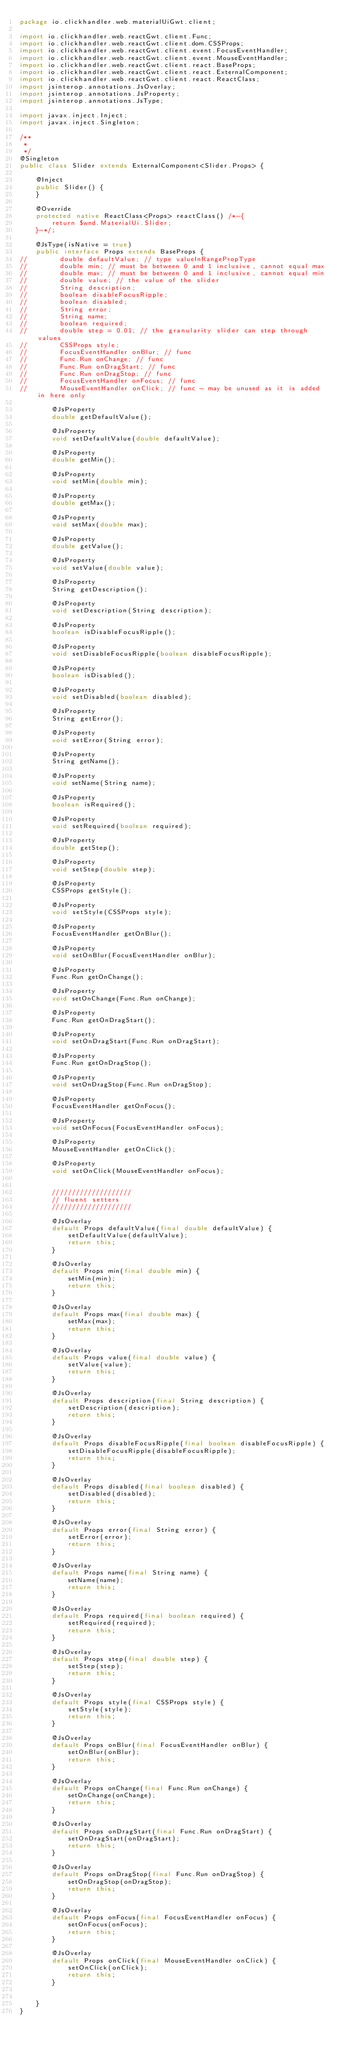Convert code to text. <code><loc_0><loc_0><loc_500><loc_500><_Java_>package io.clickhandler.web.materialUiGwt.client;

import io.clickhandler.web.reactGwt.client.Func;
import io.clickhandler.web.reactGwt.client.dom.CSSProps;
import io.clickhandler.web.reactGwt.client.event.FocusEventHandler;
import io.clickhandler.web.reactGwt.client.event.MouseEventHandler;
import io.clickhandler.web.reactGwt.client.react.BaseProps;
import io.clickhandler.web.reactGwt.client.react.ExternalComponent;
import io.clickhandler.web.reactGwt.client.react.ReactClass;
import jsinterop.annotations.JsOverlay;
import jsinterop.annotations.JsProperty;
import jsinterop.annotations.JsType;

import javax.inject.Inject;
import javax.inject.Singleton;

/**
 *
 */
@Singleton
public class Slider extends ExternalComponent<Slider.Props> {

    @Inject
    public Slider() {
    }

    @Override
    protected native ReactClass<Props> reactClass() /*-{
        return $wnd.MaterialUi.Slider;
    }-*/;

    @JsType(isNative = true)
    public interface Props extends BaseProps {
//        double defaultValue; // type valueInRangePropType
//        double min; // must be between 0 and 1 inclusive, cannot equal max
//        double max; // must be between 0 and 1 inclusive, cannot equal min
//        double value; // the value of the slider
//        String description;
//        boolean disableFocusRipple;
//        boolean disabled;
//        String error;
//        String name;
//        boolean required;
//        double step = 0.01; // the granularity slider can step through values
//        CSSProps style;
//        FocusEventHandler onBlur; // func
//        Func.Run onChange; // func
//        Func.Run onDragStart; // func
//        Func.Run onDragStop; // func
//        FocusEventHandler onFocus; // func
//        MouseEventHandler onClick; // func - may be unused as it is added in here only

        @JsProperty
        double getDefaultValue();

        @JsProperty
        void setDefaultValue(double defaultValue);

        @JsProperty
        double getMin();

        @JsProperty
        void setMin(double min);

        @JsProperty
        double getMax();

        @JsProperty
        void setMax(double max);

        @JsProperty
        double getValue();

        @JsProperty
        void setValue(double value);

        @JsProperty
        String getDescription();

        @JsProperty
        void setDescription(String description);

        @JsProperty
        boolean isDisableFocusRipple();

        @JsProperty
        void setDisableFocusRipple(boolean disableFocusRipple);

        @JsProperty
        boolean isDisabled();

        @JsProperty
        void setDisabled(boolean disabled);

        @JsProperty
        String getError();

        @JsProperty
        void setError(String error);

        @JsProperty
        String getName();

        @JsProperty
        void setName(String name);

        @JsProperty
        boolean isRequired();

        @JsProperty
        void setRequired(boolean required);

        @JsProperty
        double getStep();

        @JsProperty
        void setStep(double step);

        @JsProperty
        CSSProps getStyle();

        @JsProperty
        void setStyle(CSSProps style);

        @JsProperty
        FocusEventHandler getOnBlur();

        @JsProperty
        void setOnBlur(FocusEventHandler onBlur);

        @JsProperty
        Func.Run getOnChange();

        @JsProperty
        void setOnChange(Func.Run onChange);

        @JsProperty
        Func.Run getOnDragStart();

        @JsProperty
        void setOnDragStart(Func.Run onDragStart);

        @JsProperty
        Func.Run getOnDragStop();

        @JsProperty
        void setOnDragStop(Func.Run onDragStop);

        @JsProperty
        FocusEventHandler getOnFocus();

        @JsProperty
        void setOnFocus(FocusEventHandler onFocus);

        @JsProperty
        MouseEventHandler getOnClick();

        @JsProperty
        void setOnClick(MouseEventHandler onFocus);


        ////////////////////
        // fluent setters
        ////////////////////

        @JsOverlay
        default Props defaultValue(final double defaultValue) {
            setDefaultValue(defaultValue);
            return this;
        }

        @JsOverlay
        default Props min(final double min) {
            setMin(min);
            return this;
        }

        @JsOverlay
        default Props max(final double max) {
            setMax(max);
            return this;
        }

        @JsOverlay
        default Props value(final double value) {
            setValue(value);
            return this;
        }

        @JsOverlay
        default Props description(final String description) {
            setDescription(description);
            return this;
        }

        @JsOverlay
        default Props disableFocusRipple(final boolean disableFocusRipple) {
            setDisableFocusRipple(disableFocusRipple);
            return this;
        }

        @JsOverlay
        default Props disabled(final boolean disabled) {
            setDisabled(disabled);
            return this;
        }

        @JsOverlay
        default Props error(final String error) {
            setError(error);
            return this;
        }

        @JsOverlay
        default Props name(final String name) {
            setName(name);
            return this;
        }

        @JsOverlay
        default Props required(final boolean required) {
            setRequired(required);
            return this;
        }

        @JsOverlay
        default Props step(final double step) {
            setStep(step);
            return this;
        }

        @JsOverlay
        default Props style(final CSSProps style) {
            setStyle(style);
            return this;
        }

        @JsOverlay
        default Props onBlur(final FocusEventHandler onBlur) {
            setOnBlur(onBlur);
            return this;
        }

        @JsOverlay
        default Props onChange(final Func.Run onChange) {
            setOnChange(onChange);
            return this;
        }

        @JsOverlay
        default Props onDragStart(final Func.Run onDragStart) {
            setOnDragStart(onDragStart);
            return this;
        }

        @JsOverlay
        default Props onDragStop(final Func.Run onDragStop) {
            setOnDragStop(onDragStop);
            return this;
        }

        @JsOverlay
        default Props onFocus(final FocusEventHandler onFocus) {
            setOnFocus(onFocus);
            return this;
        }

        @JsOverlay
        default Props onClick(final MouseEventHandler onClick) {
            setOnClick(onClick);
            return this;
        }


    }
}
</code> 